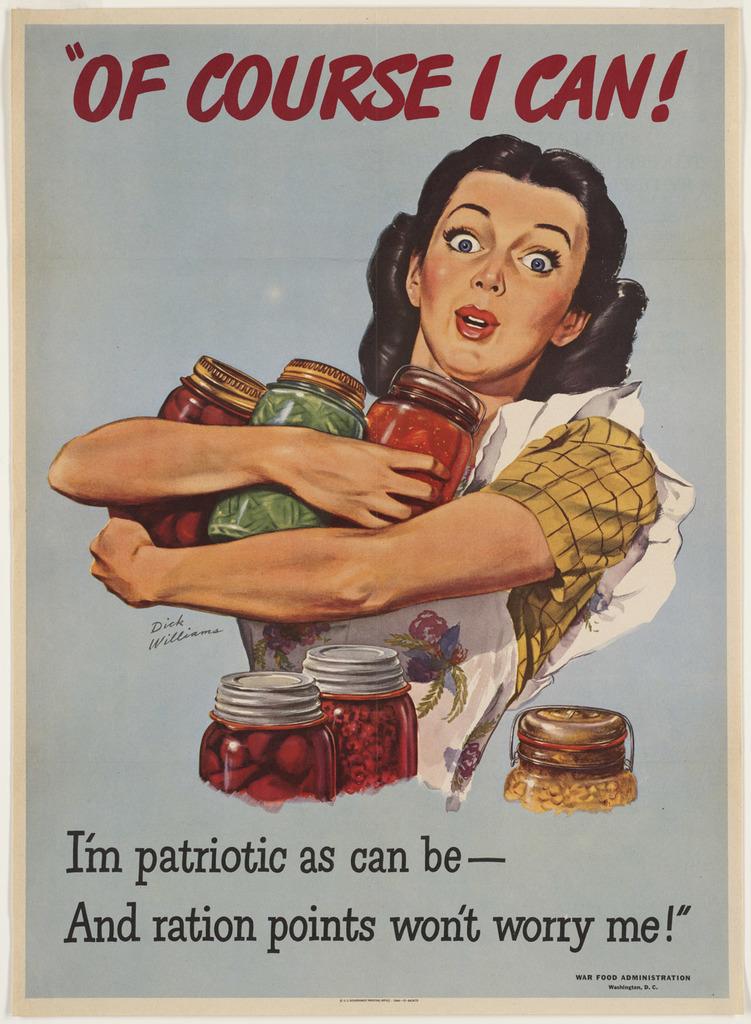What is this poster advocating for?
Provide a short and direct response. Rationing. What is this woman not worried about?
Your response must be concise. Ration points. 